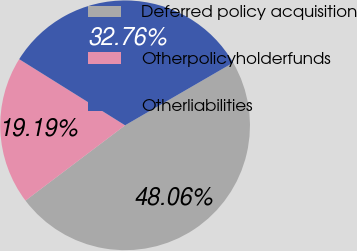Convert chart. <chart><loc_0><loc_0><loc_500><loc_500><pie_chart><fcel>Deferred policy acquisition<fcel>Otherpolicyholderfunds<fcel>Otherliabilities<nl><fcel>48.06%<fcel>19.19%<fcel>32.76%<nl></chart> 